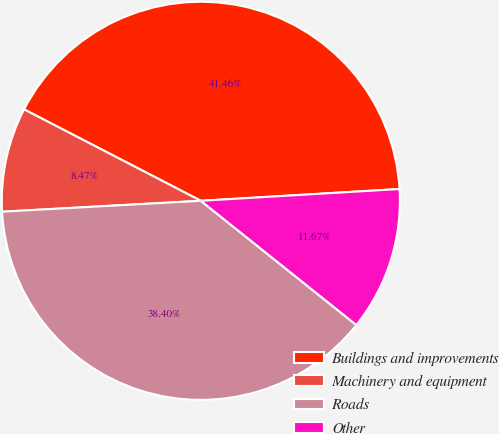Convert chart to OTSL. <chart><loc_0><loc_0><loc_500><loc_500><pie_chart><fcel>Buildings and improvements<fcel>Machinery and equipment<fcel>Roads<fcel>Other<nl><fcel>41.46%<fcel>8.47%<fcel>38.4%<fcel>11.67%<nl></chart> 